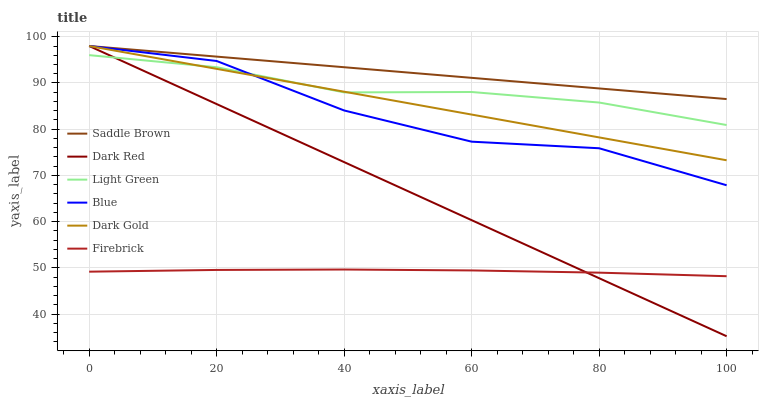Does Firebrick have the minimum area under the curve?
Answer yes or no. Yes. Does Saddle Brown have the maximum area under the curve?
Answer yes or no. Yes. Does Dark Gold have the minimum area under the curve?
Answer yes or no. No. Does Dark Gold have the maximum area under the curve?
Answer yes or no. No. Is Dark Red the smoothest?
Answer yes or no. Yes. Is Blue the roughest?
Answer yes or no. Yes. Is Dark Gold the smoothest?
Answer yes or no. No. Is Dark Gold the roughest?
Answer yes or no. No. Does Dark Red have the lowest value?
Answer yes or no. Yes. Does Dark Gold have the lowest value?
Answer yes or no. No. Does Saddle Brown have the highest value?
Answer yes or no. Yes. Does Firebrick have the highest value?
Answer yes or no. No. Is Firebrick less than Saddle Brown?
Answer yes or no. Yes. Is Blue greater than Firebrick?
Answer yes or no. Yes. Does Blue intersect Dark Red?
Answer yes or no. Yes. Is Blue less than Dark Red?
Answer yes or no. No. Is Blue greater than Dark Red?
Answer yes or no. No. Does Firebrick intersect Saddle Brown?
Answer yes or no. No. 